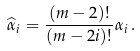Convert formula to latex. <formula><loc_0><loc_0><loc_500><loc_500>\widehat { \alpha } _ { i } = \frac { ( m - 2 ) ! } { ( m - 2 i ) ! } \alpha _ { i } \, .</formula> 